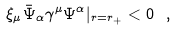Convert formula to latex. <formula><loc_0><loc_0><loc_500><loc_500>\xi _ { \mu } \bar { \Psi } _ { \alpha } \gamma ^ { \mu } \Psi ^ { \alpha } | _ { r = r _ { + } } < 0 \ ,</formula> 